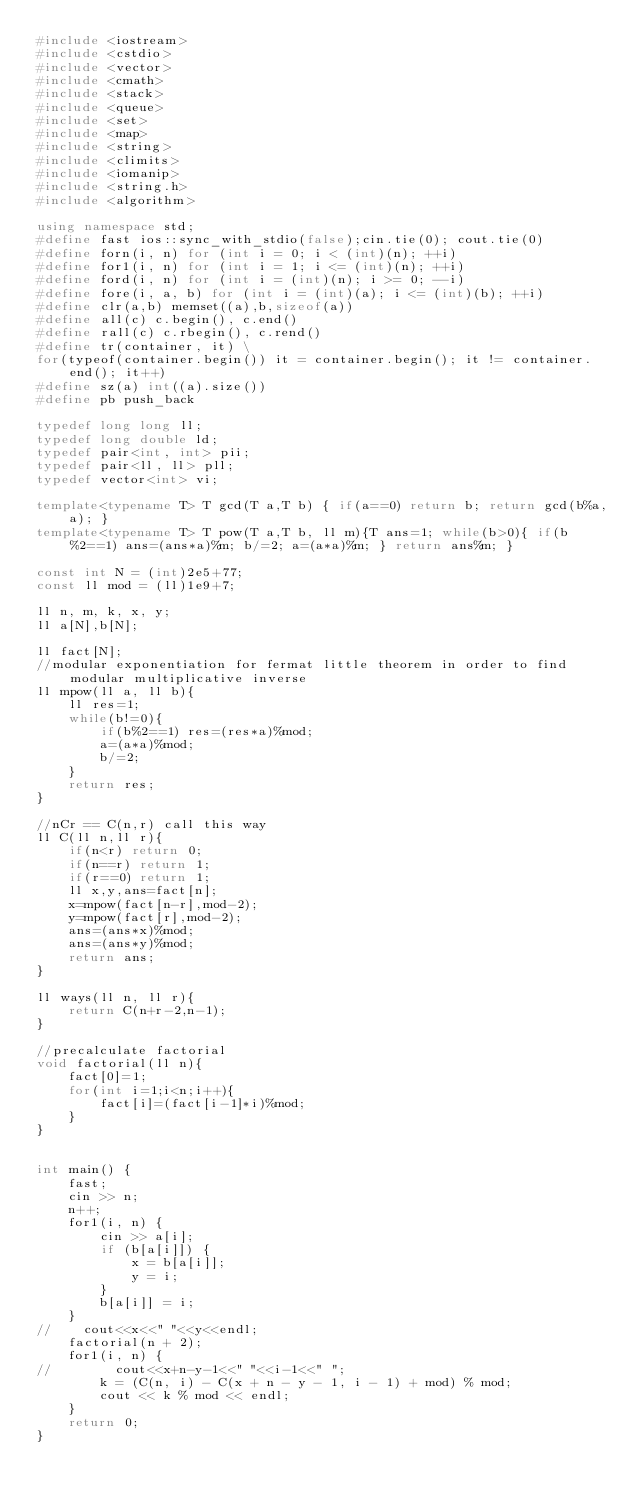<code> <loc_0><loc_0><loc_500><loc_500><_C++_>#include <iostream>
#include <cstdio>
#include <vector>
#include <cmath>
#include <stack>
#include <queue>
#include <set>
#include <map>
#include <string>
#include <climits>
#include <iomanip>
#include <string.h>
#include <algorithm>

using namespace std;
#define fast ios::sync_with_stdio(false);cin.tie(0); cout.tie(0)
#define forn(i, n) for (int i = 0; i < (int)(n); ++i)
#define for1(i, n) for (int i = 1; i <= (int)(n); ++i)
#define ford(i, n) for (int i = (int)(n); i >= 0; --i)
#define fore(i, a, b) for (int i = (int)(a); i <= (int)(b); ++i)
#define clr(a,b) memset((a),b,sizeof(a))
#define all(c) c.begin(), c.end()
#define rall(c) c.rbegin(), c.rend()
#define tr(container, it) \
for(typeof(container.begin()) it = container.begin(); it != container.end(); it++)
#define sz(a) int((a).size())
#define pb push_back

typedef long long ll;
typedef long double ld;
typedef pair<int, int> pii;
typedef pair<ll, ll> pll;
typedef vector<int> vi;

template<typename T> T gcd(T a,T b) { if(a==0) return b; return gcd(b%a,a); }
template<typename T> T pow(T a,T b, ll m){T ans=1; while(b>0){ if(b%2==1) ans=(ans*a)%m; b/=2; a=(a*a)%m; } return ans%m; }

const int N = (int)2e5+77;
const ll mod = (ll)1e9+7;

ll n, m, k, x, y;
ll a[N],b[N];

ll fact[N];
//modular exponentiation for fermat little theorem in order to find modular multiplicative inverse
ll mpow(ll a, ll b){
    ll res=1;
    while(b!=0){
        if(b%2==1) res=(res*a)%mod;
        a=(a*a)%mod;
        b/=2;
    }
    return res;
}

//nCr == C(n,r) call this way
ll C(ll n,ll r){
    if(n<r) return 0;
    if(n==r) return 1;
    if(r==0) return 1;
    ll x,y,ans=fact[n];
    x=mpow(fact[n-r],mod-2);
    y=mpow(fact[r],mod-2);
    ans=(ans*x)%mod;
    ans=(ans*y)%mod;
    return ans;
}

ll ways(ll n, ll r){
    return C(n+r-2,n-1);
}

//precalculate factorial
void factorial(ll n){
    fact[0]=1;
    for(int i=1;i<n;i++){
        fact[i]=(fact[i-1]*i)%mod;
    }
}


int main() {
    fast;
    cin >> n;
    n++;
    for1(i, n) {
        cin >> a[i];
        if (b[a[i]]) {
            x = b[a[i]];
            y = i;
        }
        b[a[i]] = i;
    }
//    cout<<x<<" "<<y<<endl;
    factorial(n + 2);
    for1(i, n) {
//        cout<<x+n-y-1<<" "<<i-1<<" ";
        k = (C(n, i) - C(x + n - y - 1, i - 1) + mod) % mod;
        cout << k % mod << endl;
    }
    return 0;
}</code> 